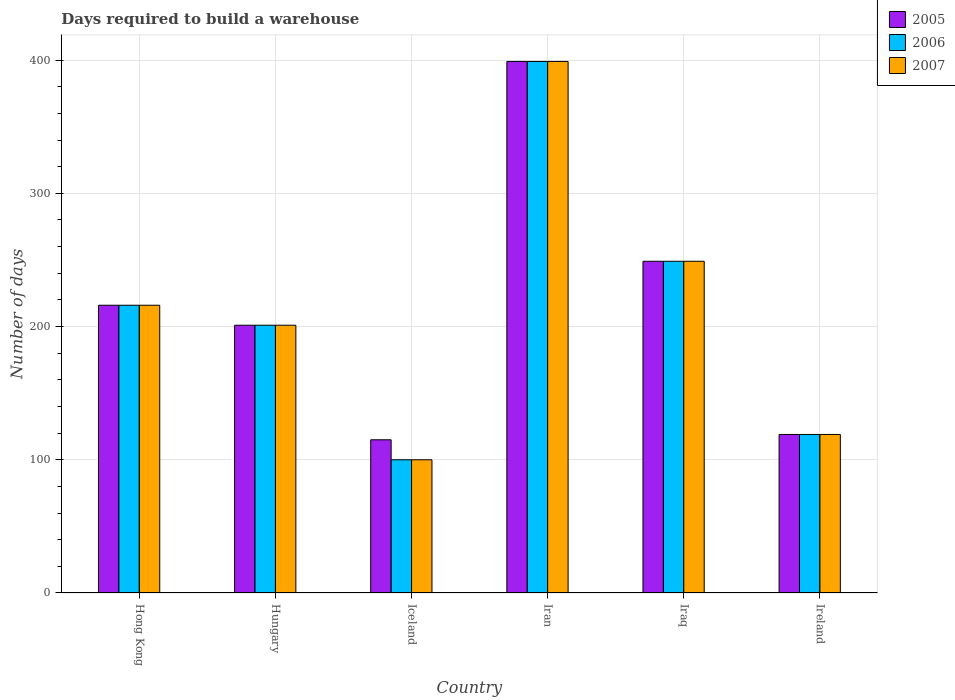How many different coloured bars are there?
Your answer should be very brief. 3. Are the number of bars on each tick of the X-axis equal?
Keep it short and to the point. Yes. How many bars are there on the 4th tick from the left?
Give a very brief answer. 3. How many bars are there on the 2nd tick from the right?
Your response must be concise. 3. What is the label of the 5th group of bars from the left?
Keep it short and to the point. Iraq. What is the days required to build a warehouse in in 2007 in Iraq?
Give a very brief answer. 249. Across all countries, what is the maximum days required to build a warehouse in in 2007?
Provide a short and direct response. 399. Across all countries, what is the minimum days required to build a warehouse in in 2007?
Offer a very short reply. 100. In which country was the days required to build a warehouse in in 2006 maximum?
Keep it short and to the point. Iran. What is the total days required to build a warehouse in in 2007 in the graph?
Ensure brevity in your answer.  1284. What is the difference between the days required to build a warehouse in in 2005 in Hong Kong and that in Iraq?
Provide a short and direct response. -33. What is the average days required to build a warehouse in in 2006 per country?
Offer a terse response. 214. What is the difference between the days required to build a warehouse in of/in 2007 and days required to build a warehouse in of/in 2005 in Hungary?
Give a very brief answer. 0. In how many countries, is the days required to build a warehouse in in 2007 greater than 280 days?
Provide a short and direct response. 1. What is the ratio of the days required to build a warehouse in in 2005 in Hungary to that in Iran?
Your answer should be compact. 0.5. Is the difference between the days required to build a warehouse in in 2007 in Hong Kong and Iceland greater than the difference between the days required to build a warehouse in in 2005 in Hong Kong and Iceland?
Offer a very short reply. Yes. What is the difference between the highest and the second highest days required to build a warehouse in in 2007?
Make the answer very short. -33. What is the difference between the highest and the lowest days required to build a warehouse in in 2005?
Make the answer very short. 284. Is the sum of the days required to build a warehouse in in 2005 in Iraq and Ireland greater than the maximum days required to build a warehouse in in 2006 across all countries?
Offer a very short reply. No. What does the 1st bar from the left in Hong Kong represents?
Provide a succinct answer. 2005. What does the 3rd bar from the right in Iran represents?
Make the answer very short. 2005. How many bars are there?
Keep it short and to the point. 18. How many countries are there in the graph?
Make the answer very short. 6. Does the graph contain any zero values?
Provide a short and direct response. No. Does the graph contain grids?
Make the answer very short. Yes. Where does the legend appear in the graph?
Ensure brevity in your answer.  Top right. How many legend labels are there?
Make the answer very short. 3. How are the legend labels stacked?
Provide a succinct answer. Vertical. What is the title of the graph?
Provide a succinct answer. Days required to build a warehouse. What is the label or title of the X-axis?
Offer a terse response. Country. What is the label or title of the Y-axis?
Ensure brevity in your answer.  Number of days. What is the Number of days in 2005 in Hong Kong?
Provide a short and direct response. 216. What is the Number of days in 2006 in Hong Kong?
Give a very brief answer. 216. What is the Number of days of 2007 in Hong Kong?
Provide a succinct answer. 216. What is the Number of days of 2005 in Hungary?
Provide a short and direct response. 201. What is the Number of days in 2006 in Hungary?
Offer a very short reply. 201. What is the Number of days of 2007 in Hungary?
Keep it short and to the point. 201. What is the Number of days in 2005 in Iceland?
Provide a short and direct response. 115. What is the Number of days in 2006 in Iceland?
Your answer should be compact. 100. What is the Number of days in 2007 in Iceland?
Your response must be concise. 100. What is the Number of days in 2005 in Iran?
Ensure brevity in your answer.  399. What is the Number of days of 2006 in Iran?
Offer a very short reply. 399. What is the Number of days of 2007 in Iran?
Your answer should be very brief. 399. What is the Number of days of 2005 in Iraq?
Ensure brevity in your answer.  249. What is the Number of days in 2006 in Iraq?
Ensure brevity in your answer.  249. What is the Number of days in 2007 in Iraq?
Offer a very short reply. 249. What is the Number of days in 2005 in Ireland?
Ensure brevity in your answer.  119. What is the Number of days of 2006 in Ireland?
Offer a very short reply. 119. What is the Number of days in 2007 in Ireland?
Ensure brevity in your answer.  119. Across all countries, what is the maximum Number of days in 2005?
Ensure brevity in your answer.  399. Across all countries, what is the maximum Number of days in 2006?
Your answer should be very brief. 399. Across all countries, what is the maximum Number of days in 2007?
Your response must be concise. 399. Across all countries, what is the minimum Number of days in 2005?
Offer a very short reply. 115. What is the total Number of days of 2005 in the graph?
Offer a terse response. 1299. What is the total Number of days of 2006 in the graph?
Give a very brief answer. 1284. What is the total Number of days in 2007 in the graph?
Your response must be concise. 1284. What is the difference between the Number of days of 2005 in Hong Kong and that in Iceland?
Your response must be concise. 101. What is the difference between the Number of days in 2006 in Hong Kong and that in Iceland?
Ensure brevity in your answer.  116. What is the difference between the Number of days in 2007 in Hong Kong and that in Iceland?
Offer a very short reply. 116. What is the difference between the Number of days in 2005 in Hong Kong and that in Iran?
Offer a very short reply. -183. What is the difference between the Number of days in 2006 in Hong Kong and that in Iran?
Ensure brevity in your answer.  -183. What is the difference between the Number of days in 2007 in Hong Kong and that in Iran?
Ensure brevity in your answer.  -183. What is the difference between the Number of days of 2005 in Hong Kong and that in Iraq?
Your answer should be compact. -33. What is the difference between the Number of days of 2006 in Hong Kong and that in Iraq?
Provide a short and direct response. -33. What is the difference between the Number of days in 2007 in Hong Kong and that in Iraq?
Keep it short and to the point. -33. What is the difference between the Number of days of 2005 in Hong Kong and that in Ireland?
Your answer should be very brief. 97. What is the difference between the Number of days in 2006 in Hong Kong and that in Ireland?
Offer a terse response. 97. What is the difference between the Number of days in 2007 in Hong Kong and that in Ireland?
Offer a terse response. 97. What is the difference between the Number of days in 2005 in Hungary and that in Iceland?
Ensure brevity in your answer.  86. What is the difference between the Number of days of 2006 in Hungary and that in Iceland?
Give a very brief answer. 101. What is the difference between the Number of days of 2007 in Hungary and that in Iceland?
Offer a very short reply. 101. What is the difference between the Number of days in 2005 in Hungary and that in Iran?
Give a very brief answer. -198. What is the difference between the Number of days in 2006 in Hungary and that in Iran?
Make the answer very short. -198. What is the difference between the Number of days of 2007 in Hungary and that in Iran?
Keep it short and to the point. -198. What is the difference between the Number of days of 2005 in Hungary and that in Iraq?
Your response must be concise. -48. What is the difference between the Number of days in 2006 in Hungary and that in Iraq?
Offer a terse response. -48. What is the difference between the Number of days in 2007 in Hungary and that in Iraq?
Provide a succinct answer. -48. What is the difference between the Number of days of 2005 in Hungary and that in Ireland?
Provide a short and direct response. 82. What is the difference between the Number of days in 2006 in Hungary and that in Ireland?
Your answer should be very brief. 82. What is the difference between the Number of days of 2005 in Iceland and that in Iran?
Offer a very short reply. -284. What is the difference between the Number of days in 2006 in Iceland and that in Iran?
Keep it short and to the point. -299. What is the difference between the Number of days in 2007 in Iceland and that in Iran?
Offer a very short reply. -299. What is the difference between the Number of days in 2005 in Iceland and that in Iraq?
Your answer should be compact. -134. What is the difference between the Number of days in 2006 in Iceland and that in Iraq?
Offer a very short reply. -149. What is the difference between the Number of days of 2007 in Iceland and that in Iraq?
Offer a terse response. -149. What is the difference between the Number of days of 2005 in Iceland and that in Ireland?
Provide a short and direct response. -4. What is the difference between the Number of days of 2005 in Iran and that in Iraq?
Offer a very short reply. 150. What is the difference between the Number of days of 2006 in Iran and that in Iraq?
Offer a very short reply. 150. What is the difference between the Number of days of 2007 in Iran and that in Iraq?
Give a very brief answer. 150. What is the difference between the Number of days in 2005 in Iran and that in Ireland?
Your answer should be compact. 280. What is the difference between the Number of days in 2006 in Iran and that in Ireland?
Make the answer very short. 280. What is the difference between the Number of days of 2007 in Iran and that in Ireland?
Your response must be concise. 280. What is the difference between the Number of days in 2005 in Iraq and that in Ireland?
Offer a very short reply. 130. What is the difference between the Number of days in 2006 in Iraq and that in Ireland?
Your answer should be very brief. 130. What is the difference between the Number of days in 2007 in Iraq and that in Ireland?
Keep it short and to the point. 130. What is the difference between the Number of days of 2005 in Hong Kong and the Number of days of 2007 in Hungary?
Provide a short and direct response. 15. What is the difference between the Number of days in 2006 in Hong Kong and the Number of days in 2007 in Hungary?
Provide a succinct answer. 15. What is the difference between the Number of days of 2005 in Hong Kong and the Number of days of 2006 in Iceland?
Your answer should be very brief. 116. What is the difference between the Number of days of 2005 in Hong Kong and the Number of days of 2007 in Iceland?
Give a very brief answer. 116. What is the difference between the Number of days of 2006 in Hong Kong and the Number of days of 2007 in Iceland?
Your answer should be very brief. 116. What is the difference between the Number of days in 2005 in Hong Kong and the Number of days in 2006 in Iran?
Your response must be concise. -183. What is the difference between the Number of days in 2005 in Hong Kong and the Number of days in 2007 in Iran?
Make the answer very short. -183. What is the difference between the Number of days of 2006 in Hong Kong and the Number of days of 2007 in Iran?
Make the answer very short. -183. What is the difference between the Number of days in 2005 in Hong Kong and the Number of days in 2006 in Iraq?
Ensure brevity in your answer.  -33. What is the difference between the Number of days of 2005 in Hong Kong and the Number of days of 2007 in Iraq?
Provide a short and direct response. -33. What is the difference between the Number of days of 2006 in Hong Kong and the Number of days of 2007 in Iraq?
Keep it short and to the point. -33. What is the difference between the Number of days of 2005 in Hong Kong and the Number of days of 2006 in Ireland?
Ensure brevity in your answer.  97. What is the difference between the Number of days in 2005 in Hong Kong and the Number of days in 2007 in Ireland?
Your response must be concise. 97. What is the difference between the Number of days of 2006 in Hong Kong and the Number of days of 2007 in Ireland?
Offer a very short reply. 97. What is the difference between the Number of days of 2005 in Hungary and the Number of days of 2006 in Iceland?
Ensure brevity in your answer.  101. What is the difference between the Number of days in 2005 in Hungary and the Number of days in 2007 in Iceland?
Provide a succinct answer. 101. What is the difference between the Number of days in 2006 in Hungary and the Number of days in 2007 in Iceland?
Make the answer very short. 101. What is the difference between the Number of days of 2005 in Hungary and the Number of days of 2006 in Iran?
Make the answer very short. -198. What is the difference between the Number of days of 2005 in Hungary and the Number of days of 2007 in Iran?
Make the answer very short. -198. What is the difference between the Number of days of 2006 in Hungary and the Number of days of 2007 in Iran?
Provide a short and direct response. -198. What is the difference between the Number of days of 2005 in Hungary and the Number of days of 2006 in Iraq?
Make the answer very short. -48. What is the difference between the Number of days of 2005 in Hungary and the Number of days of 2007 in Iraq?
Keep it short and to the point. -48. What is the difference between the Number of days in 2006 in Hungary and the Number of days in 2007 in Iraq?
Offer a terse response. -48. What is the difference between the Number of days of 2005 in Hungary and the Number of days of 2006 in Ireland?
Offer a terse response. 82. What is the difference between the Number of days of 2005 in Hungary and the Number of days of 2007 in Ireland?
Your answer should be compact. 82. What is the difference between the Number of days in 2006 in Hungary and the Number of days in 2007 in Ireland?
Keep it short and to the point. 82. What is the difference between the Number of days in 2005 in Iceland and the Number of days in 2006 in Iran?
Provide a short and direct response. -284. What is the difference between the Number of days in 2005 in Iceland and the Number of days in 2007 in Iran?
Give a very brief answer. -284. What is the difference between the Number of days in 2006 in Iceland and the Number of days in 2007 in Iran?
Ensure brevity in your answer.  -299. What is the difference between the Number of days in 2005 in Iceland and the Number of days in 2006 in Iraq?
Your answer should be very brief. -134. What is the difference between the Number of days in 2005 in Iceland and the Number of days in 2007 in Iraq?
Offer a very short reply. -134. What is the difference between the Number of days of 2006 in Iceland and the Number of days of 2007 in Iraq?
Ensure brevity in your answer.  -149. What is the difference between the Number of days of 2005 in Iceland and the Number of days of 2006 in Ireland?
Offer a terse response. -4. What is the difference between the Number of days in 2006 in Iceland and the Number of days in 2007 in Ireland?
Offer a very short reply. -19. What is the difference between the Number of days of 2005 in Iran and the Number of days of 2006 in Iraq?
Give a very brief answer. 150. What is the difference between the Number of days of 2005 in Iran and the Number of days of 2007 in Iraq?
Give a very brief answer. 150. What is the difference between the Number of days of 2006 in Iran and the Number of days of 2007 in Iraq?
Give a very brief answer. 150. What is the difference between the Number of days of 2005 in Iran and the Number of days of 2006 in Ireland?
Give a very brief answer. 280. What is the difference between the Number of days in 2005 in Iran and the Number of days in 2007 in Ireland?
Your response must be concise. 280. What is the difference between the Number of days of 2006 in Iran and the Number of days of 2007 in Ireland?
Your answer should be compact. 280. What is the difference between the Number of days of 2005 in Iraq and the Number of days of 2006 in Ireland?
Provide a short and direct response. 130. What is the difference between the Number of days of 2005 in Iraq and the Number of days of 2007 in Ireland?
Provide a short and direct response. 130. What is the difference between the Number of days of 2006 in Iraq and the Number of days of 2007 in Ireland?
Give a very brief answer. 130. What is the average Number of days of 2005 per country?
Provide a short and direct response. 216.5. What is the average Number of days in 2006 per country?
Offer a very short reply. 214. What is the average Number of days of 2007 per country?
Your answer should be very brief. 214. What is the difference between the Number of days in 2005 and Number of days in 2006 in Hong Kong?
Ensure brevity in your answer.  0. What is the difference between the Number of days in 2005 and Number of days in 2006 in Iran?
Keep it short and to the point. 0. What is the difference between the Number of days in 2005 and Number of days in 2007 in Iraq?
Give a very brief answer. 0. What is the difference between the Number of days of 2005 and Number of days of 2006 in Ireland?
Offer a very short reply. 0. What is the difference between the Number of days of 2005 and Number of days of 2007 in Ireland?
Your response must be concise. 0. What is the ratio of the Number of days in 2005 in Hong Kong to that in Hungary?
Your answer should be compact. 1.07. What is the ratio of the Number of days of 2006 in Hong Kong to that in Hungary?
Ensure brevity in your answer.  1.07. What is the ratio of the Number of days in 2007 in Hong Kong to that in Hungary?
Provide a succinct answer. 1.07. What is the ratio of the Number of days of 2005 in Hong Kong to that in Iceland?
Offer a very short reply. 1.88. What is the ratio of the Number of days of 2006 in Hong Kong to that in Iceland?
Provide a succinct answer. 2.16. What is the ratio of the Number of days of 2007 in Hong Kong to that in Iceland?
Your response must be concise. 2.16. What is the ratio of the Number of days of 2005 in Hong Kong to that in Iran?
Offer a terse response. 0.54. What is the ratio of the Number of days of 2006 in Hong Kong to that in Iran?
Make the answer very short. 0.54. What is the ratio of the Number of days in 2007 in Hong Kong to that in Iran?
Ensure brevity in your answer.  0.54. What is the ratio of the Number of days of 2005 in Hong Kong to that in Iraq?
Keep it short and to the point. 0.87. What is the ratio of the Number of days of 2006 in Hong Kong to that in Iraq?
Give a very brief answer. 0.87. What is the ratio of the Number of days of 2007 in Hong Kong to that in Iraq?
Offer a very short reply. 0.87. What is the ratio of the Number of days of 2005 in Hong Kong to that in Ireland?
Provide a short and direct response. 1.82. What is the ratio of the Number of days of 2006 in Hong Kong to that in Ireland?
Offer a terse response. 1.82. What is the ratio of the Number of days in 2007 in Hong Kong to that in Ireland?
Offer a very short reply. 1.82. What is the ratio of the Number of days of 2005 in Hungary to that in Iceland?
Your answer should be compact. 1.75. What is the ratio of the Number of days of 2006 in Hungary to that in Iceland?
Ensure brevity in your answer.  2.01. What is the ratio of the Number of days of 2007 in Hungary to that in Iceland?
Provide a succinct answer. 2.01. What is the ratio of the Number of days of 2005 in Hungary to that in Iran?
Provide a short and direct response. 0.5. What is the ratio of the Number of days of 2006 in Hungary to that in Iran?
Offer a terse response. 0.5. What is the ratio of the Number of days in 2007 in Hungary to that in Iran?
Your response must be concise. 0.5. What is the ratio of the Number of days in 2005 in Hungary to that in Iraq?
Your answer should be compact. 0.81. What is the ratio of the Number of days in 2006 in Hungary to that in Iraq?
Provide a succinct answer. 0.81. What is the ratio of the Number of days of 2007 in Hungary to that in Iraq?
Give a very brief answer. 0.81. What is the ratio of the Number of days of 2005 in Hungary to that in Ireland?
Give a very brief answer. 1.69. What is the ratio of the Number of days of 2006 in Hungary to that in Ireland?
Offer a very short reply. 1.69. What is the ratio of the Number of days of 2007 in Hungary to that in Ireland?
Provide a succinct answer. 1.69. What is the ratio of the Number of days in 2005 in Iceland to that in Iran?
Offer a very short reply. 0.29. What is the ratio of the Number of days in 2006 in Iceland to that in Iran?
Your response must be concise. 0.25. What is the ratio of the Number of days in 2007 in Iceland to that in Iran?
Provide a succinct answer. 0.25. What is the ratio of the Number of days of 2005 in Iceland to that in Iraq?
Provide a short and direct response. 0.46. What is the ratio of the Number of days in 2006 in Iceland to that in Iraq?
Make the answer very short. 0.4. What is the ratio of the Number of days in 2007 in Iceland to that in Iraq?
Provide a short and direct response. 0.4. What is the ratio of the Number of days of 2005 in Iceland to that in Ireland?
Your response must be concise. 0.97. What is the ratio of the Number of days of 2006 in Iceland to that in Ireland?
Provide a succinct answer. 0.84. What is the ratio of the Number of days in 2007 in Iceland to that in Ireland?
Give a very brief answer. 0.84. What is the ratio of the Number of days of 2005 in Iran to that in Iraq?
Provide a succinct answer. 1.6. What is the ratio of the Number of days in 2006 in Iran to that in Iraq?
Ensure brevity in your answer.  1.6. What is the ratio of the Number of days of 2007 in Iran to that in Iraq?
Offer a very short reply. 1.6. What is the ratio of the Number of days of 2005 in Iran to that in Ireland?
Offer a terse response. 3.35. What is the ratio of the Number of days in 2006 in Iran to that in Ireland?
Ensure brevity in your answer.  3.35. What is the ratio of the Number of days of 2007 in Iran to that in Ireland?
Offer a very short reply. 3.35. What is the ratio of the Number of days of 2005 in Iraq to that in Ireland?
Your answer should be very brief. 2.09. What is the ratio of the Number of days in 2006 in Iraq to that in Ireland?
Your answer should be very brief. 2.09. What is the ratio of the Number of days in 2007 in Iraq to that in Ireland?
Your answer should be compact. 2.09. What is the difference between the highest and the second highest Number of days in 2005?
Give a very brief answer. 150. What is the difference between the highest and the second highest Number of days of 2006?
Give a very brief answer. 150. What is the difference between the highest and the second highest Number of days of 2007?
Your answer should be very brief. 150. What is the difference between the highest and the lowest Number of days in 2005?
Keep it short and to the point. 284. What is the difference between the highest and the lowest Number of days of 2006?
Keep it short and to the point. 299. What is the difference between the highest and the lowest Number of days of 2007?
Offer a terse response. 299. 